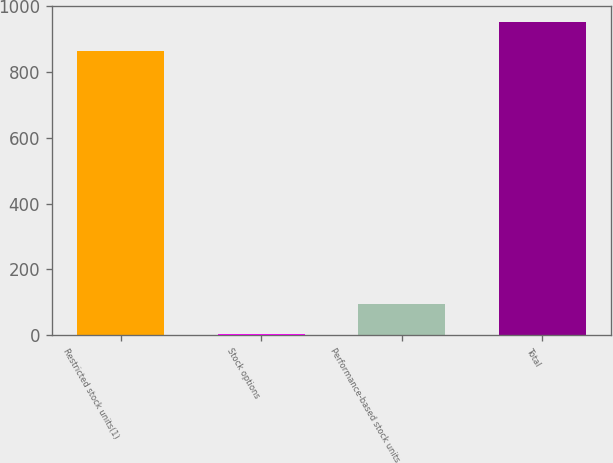<chart> <loc_0><loc_0><loc_500><loc_500><bar_chart><fcel>Restricted stock units(1)<fcel>Stock options<fcel>Performance-based stock units<fcel>Total<nl><fcel>864<fcel>4<fcel>93.3<fcel>953.3<nl></chart> 